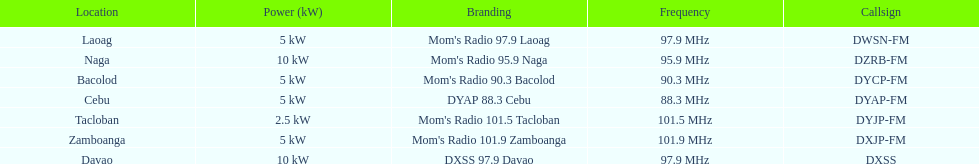What is the difference in kw between naga and bacolod radio? 5 kW. 